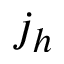<formula> <loc_0><loc_0><loc_500><loc_500>j _ { h }</formula> 